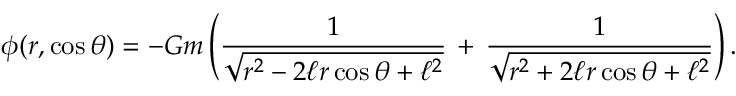Convert formula to latex. <formula><loc_0><loc_0><loc_500><loc_500>\phi ( r , \cos \theta ) = - G m \left ( \frac { 1 } { \sqrt { r ^ { 2 } - 2 \ell r \cos \theta + \ell ^ { 2 } } } \, + \, \frac { 1 } { \sqrt { r ^ { 2 } + 2 \ell r \cos \theta + \ell ^ { 2 } } } \right ) .</formula> 